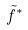Convert formula to latex. <formula><loc_0><loc_0><loc_500><loc_500>\tilde { f } ^ { * }</formula> 